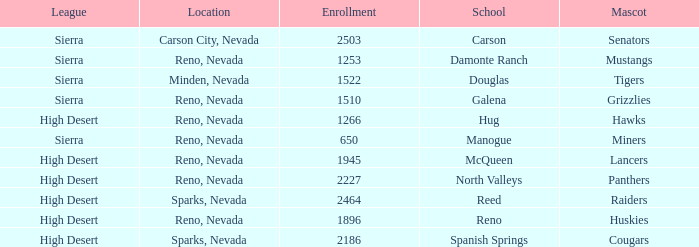Which school has the Raiders as their mascot? Reed. 